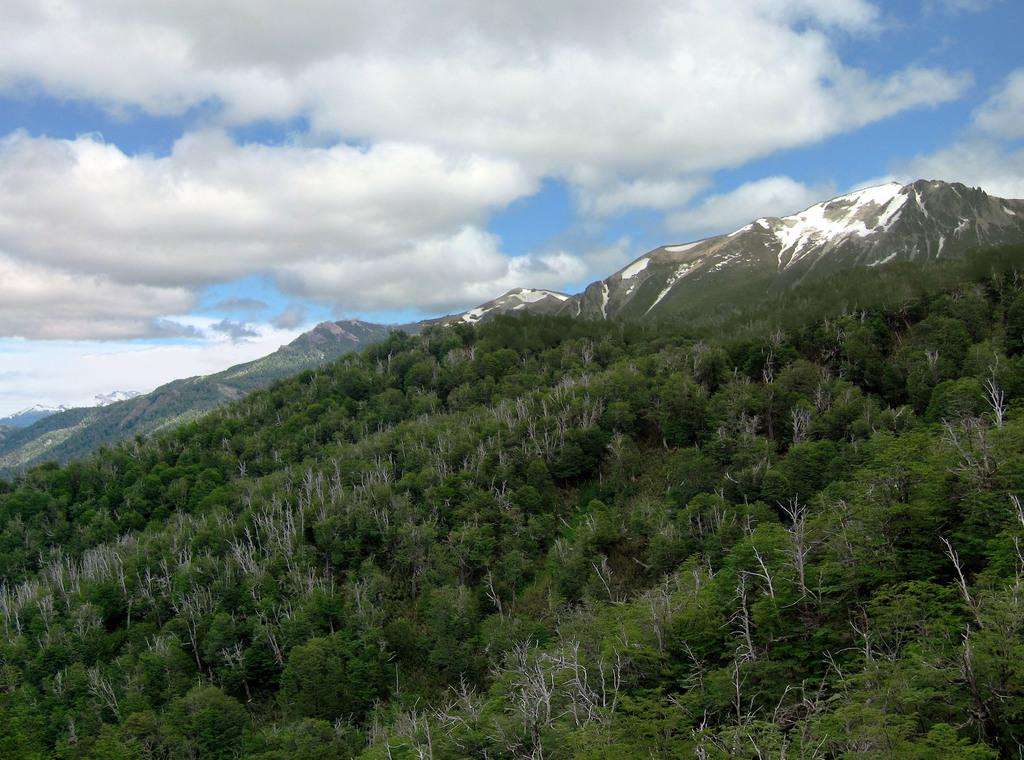What type of vegetation is present at the bottom of the image? There are trees at the bottom of the image. What geographical feature can be seen in the middle of the image? There are mountains with snow in the middle of the image. What is the condition of the sky in the image? The sky is cloudy at the top of the image. Where is the bucket located in the image? There is no bucket present in the image. Can you spot any snakes in the image? There are no snakes present in the image. 